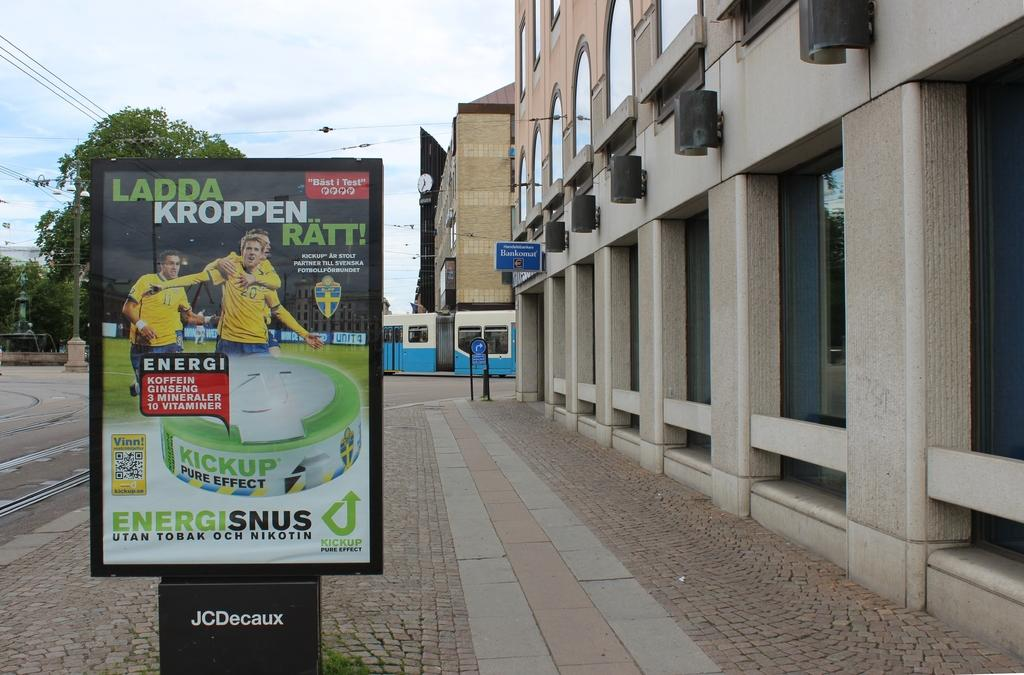<image>
Create a compact narrative representing the image presented. Ladda Kroppen sign for enegisinus on a board outside 